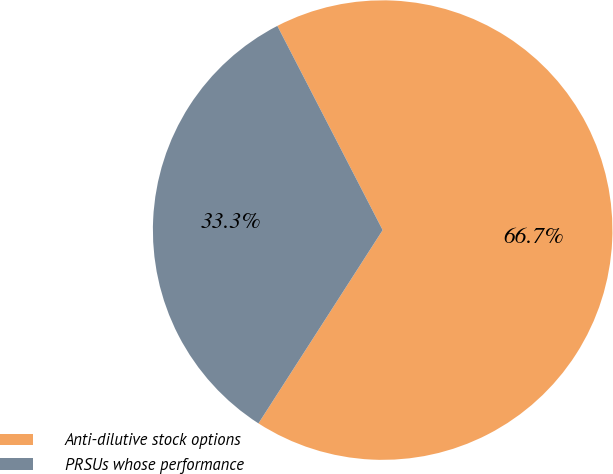<chart> <loc_0><loc_0><loc_500><loc_500><pie_chart><fcel>Anti-dilutive stock options<fcel>PRSUs whose performance<nl><fcel>66.67%<fcel>33.33%<nl></chart> 